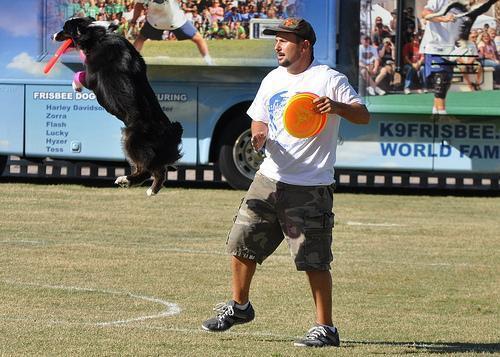How many dogs are there?
Give a very brief answer. 1. How many men are there?
Give a very brief answer. 1. 